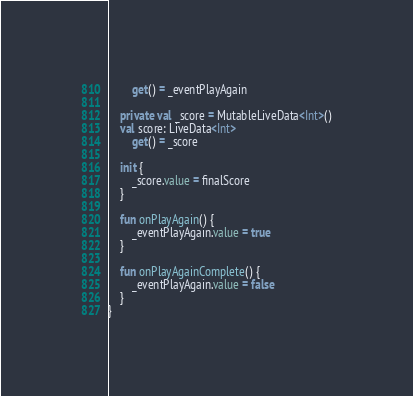Convert code to text. <code><loc_0><loc_0><loc_500><loc_500><_Kotlin_>        get() = _eventPlayAgain

    private val _score = MutableLiveData<Int>()
    val score: LiveData<Int>
        get() = _score

    init {
        _score.value = finalScore
    }

    fun onPlayAgain() {
        _eventPlayAgain.value = true
    }

    fun onPlayAgainComplete() {
        _eventPlayAgain.value = false
    }
}</code> 